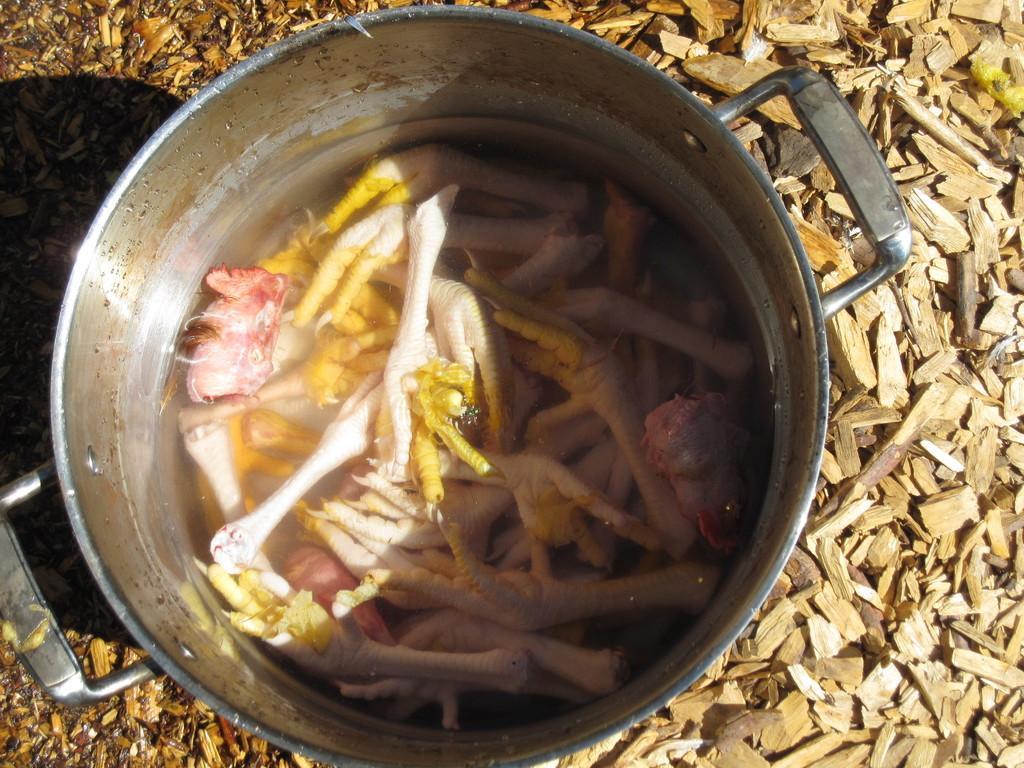In one or two sentences, can you explain what this image depicts? In this picture we can see meat in a bowl on the ground and in the background we can see wooden sticks. 